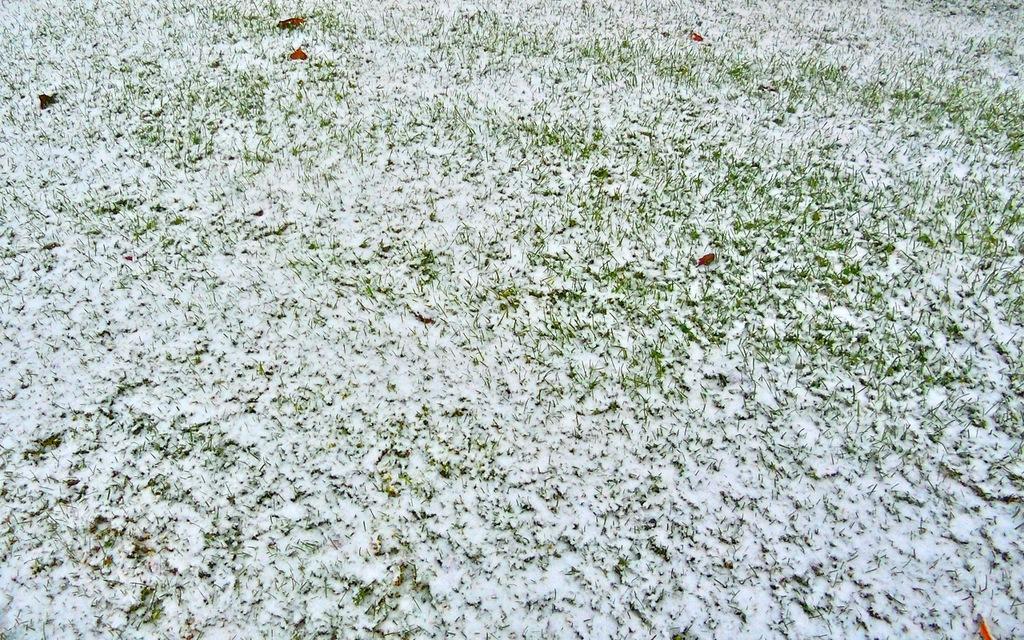How would you summarize this image in a sentence or two? Here we can see snow on the grass. 